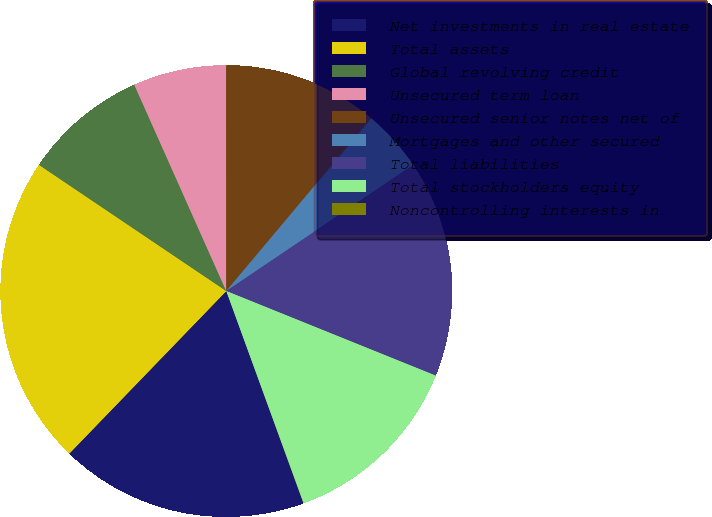Convert chart to OTSL. <chart><loc_0><loc_0><loc_500><loc_500><pie_chart><fcel>Net investments in real estate<fcel>Total assets<fcel>Global revolving credit<fcel>Unsecured term loan<fcel>Unsecured senior notes net of<fcel>Mortgages and other secured<fcel>Total liabilities<fcel>Total stockholders equity<fcel>Noncontrolling interests in<nl><fcel>17.77%<fcel>22.21%<fcel>8.89%<fcel>6.67%<fcel>11.11%<fcel>4.45%<fcel>15.55%<fcel>13.33%<fcel>0.01%<nl></chart> 